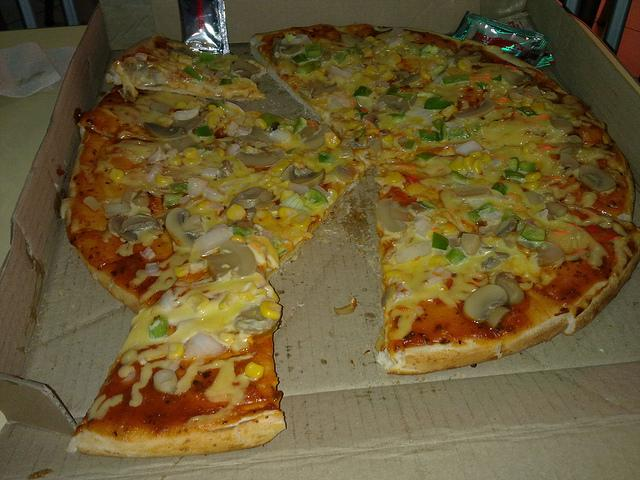What vegetable is the unusual one on the pizza? corn 